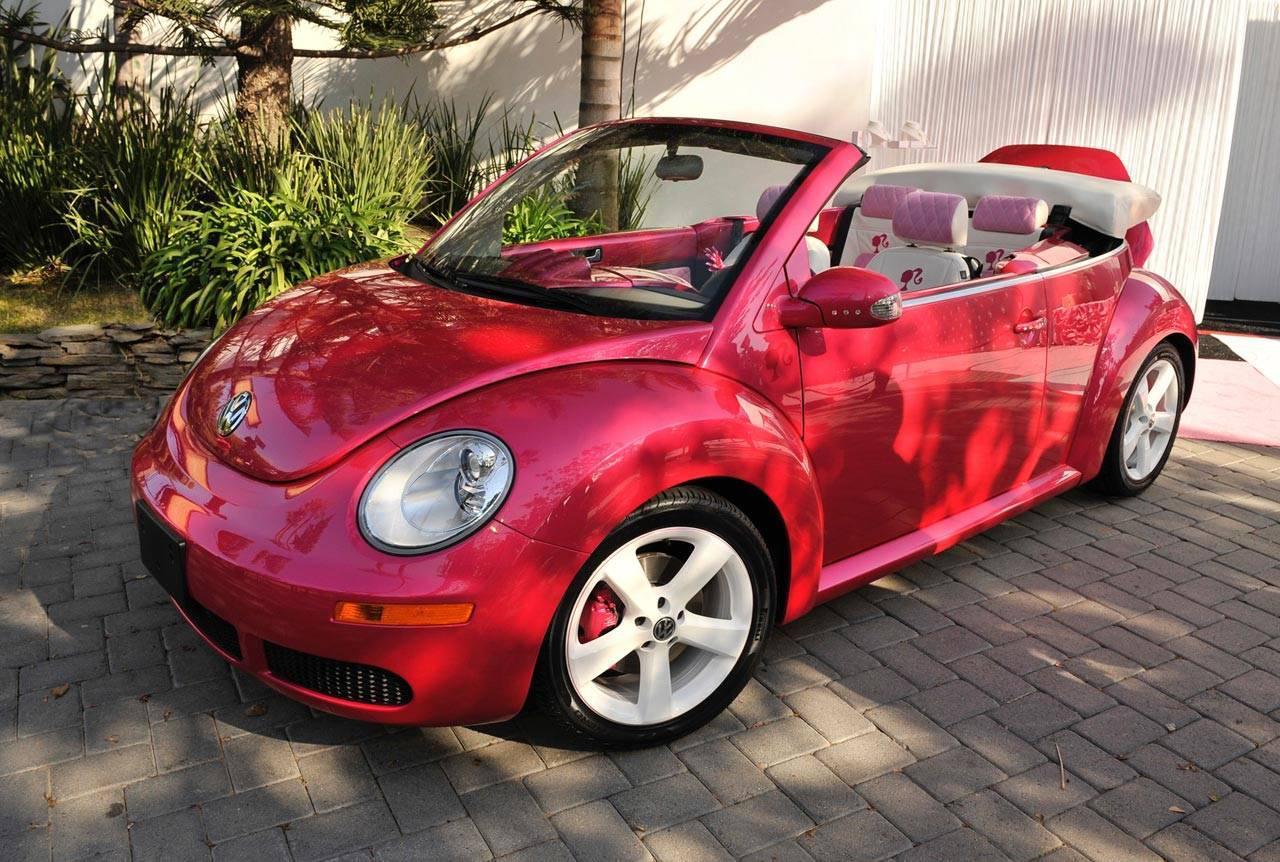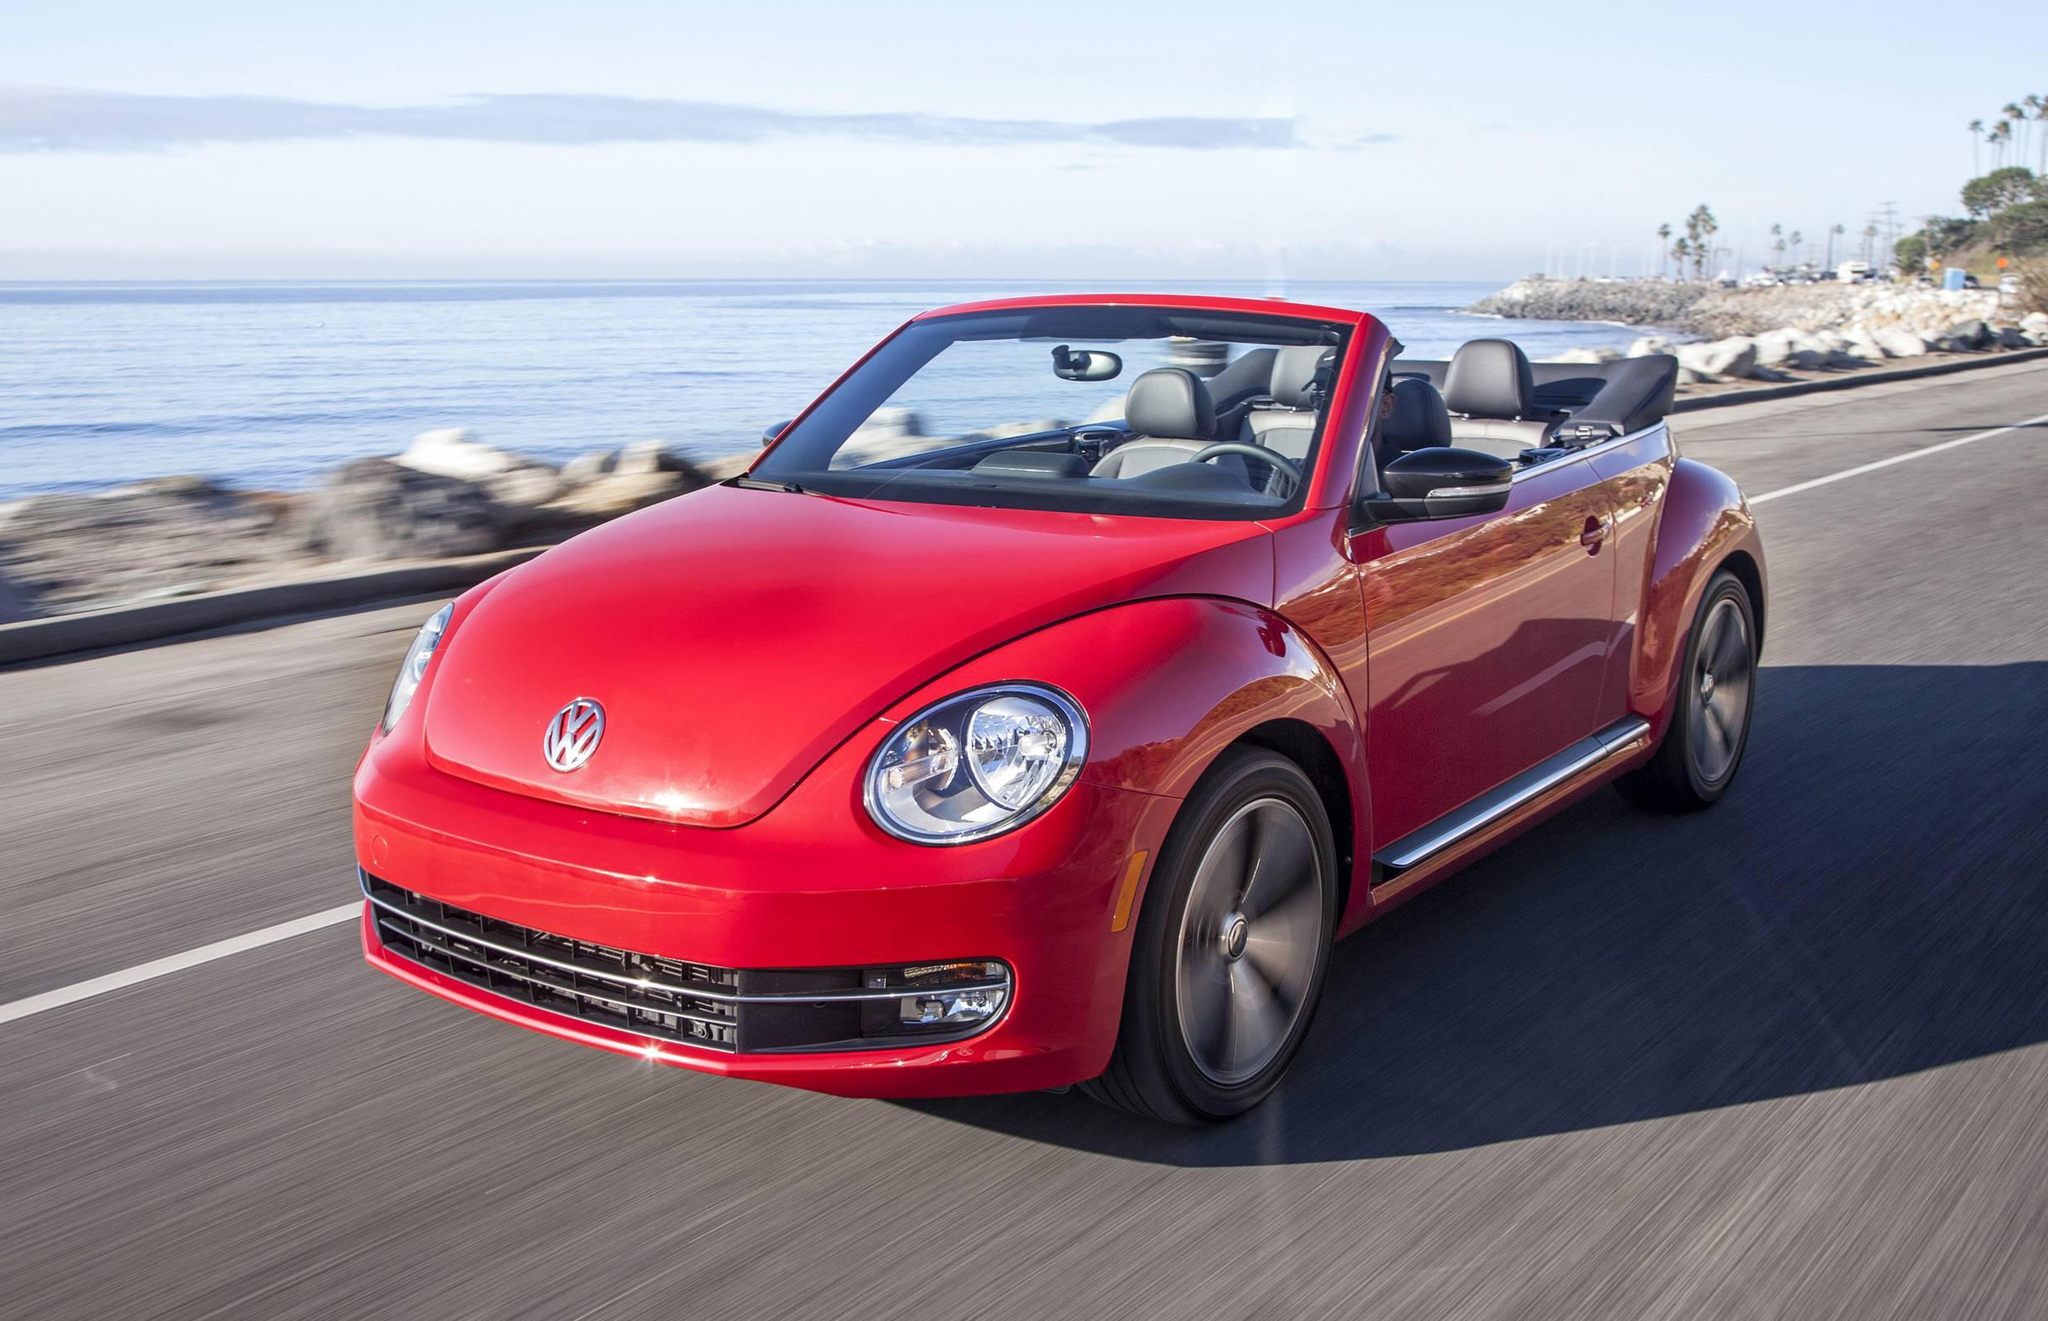The first image is the image on the left, the second image is the image on the right. Considering the images on both sides, is "In one image, a red convertible is near a body of water, while in a second image, a red car is parked in front of an area of greenery and a white structure." valid? Answer yes or no. Yes. The first image is the image on the left, the second image is the image on the right. Analyze the images presented: Is the assertion "Right image shows a red forward-angled convertible alongside a rocky shoreline." valid? Answer yes or no. Yes. 